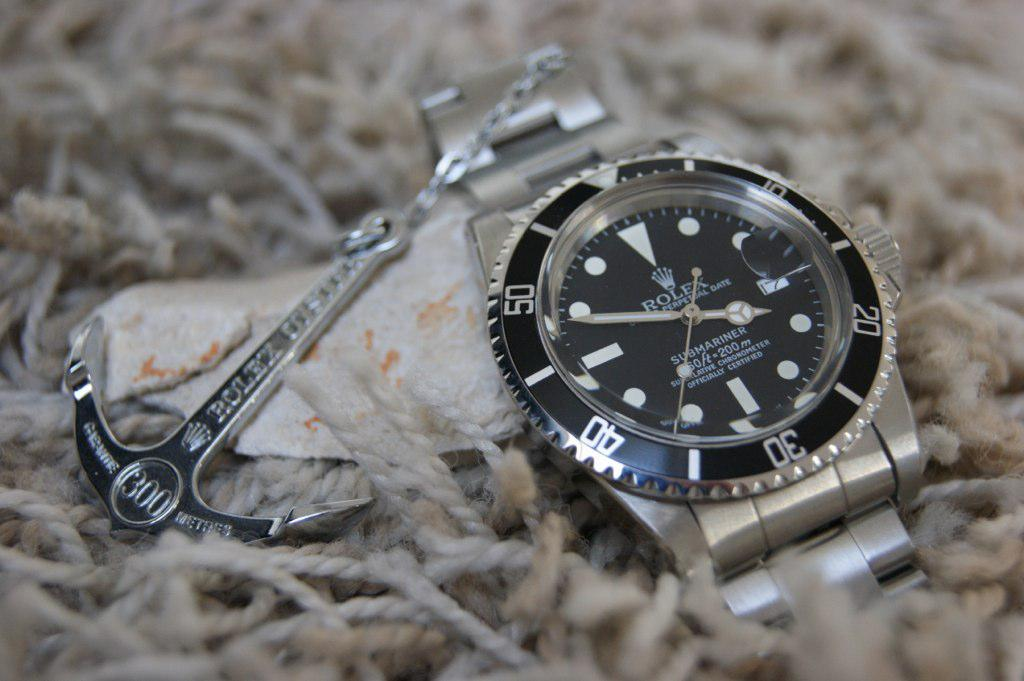<image>
Render a clear and concise summary of the photo. Silver and black watch for the brand named ROLEX. 